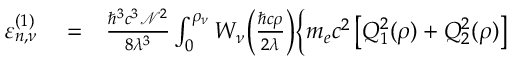<formula> <loc_0><loc_0><loc_500><loc_500>\begin{array} { r l r } { \varepsilon _ { n , \nu } ^ { ( 1 ) } } & = } & { \frac { \hbar { ^ } { 3 } c ^ { 3 } \mathcal { N } ^ { 2 } } { 8 \lambda ^ { 3 } } \int _ { 0 } ^ { \rho _ { \nu } } W _ { \nu } \Big ( \frac { \hbar { c } \rho } { 2 \lambda } \Big ) \Big \{ m _ { e } c ^ { 2 } \, \Big [ Q _ { 1 } ^ { 2 } ( \rho ) + Q _ { 2 } ^ { 2 } ( \rho ) \Big ] } \end{array}</formula> 